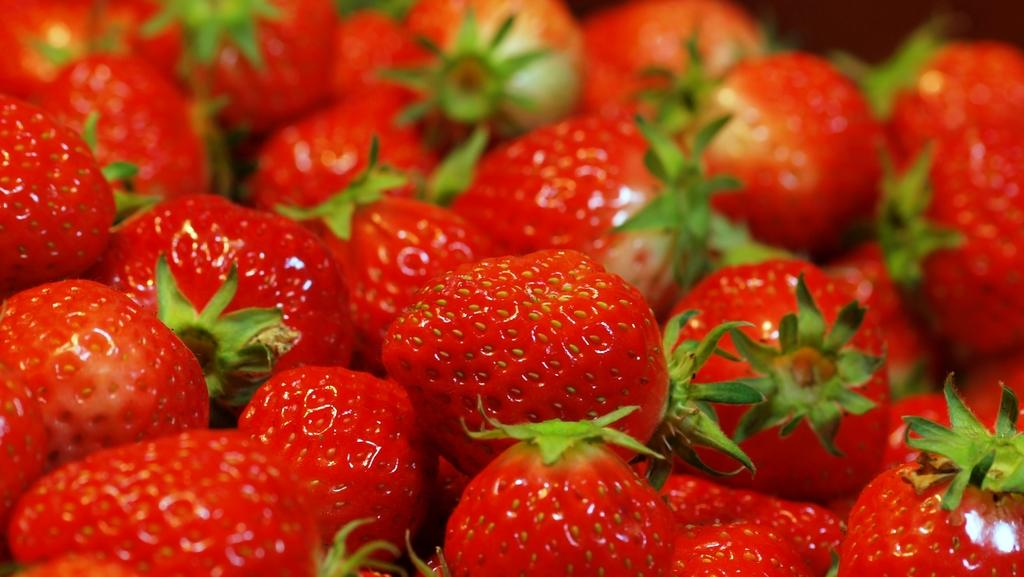What type of fruit is predominantly featured in the image? There are many strawberries in the image. Can you describe the arrangement of the strawberries? The facts provided do not specify the arrangement of the strawberries. What color are the strawberries in the image? The strawberries in the image are typically red. What type of pancake is being served with the strawberries in the image? There is no pancake present in the image; it only features strawberries. 